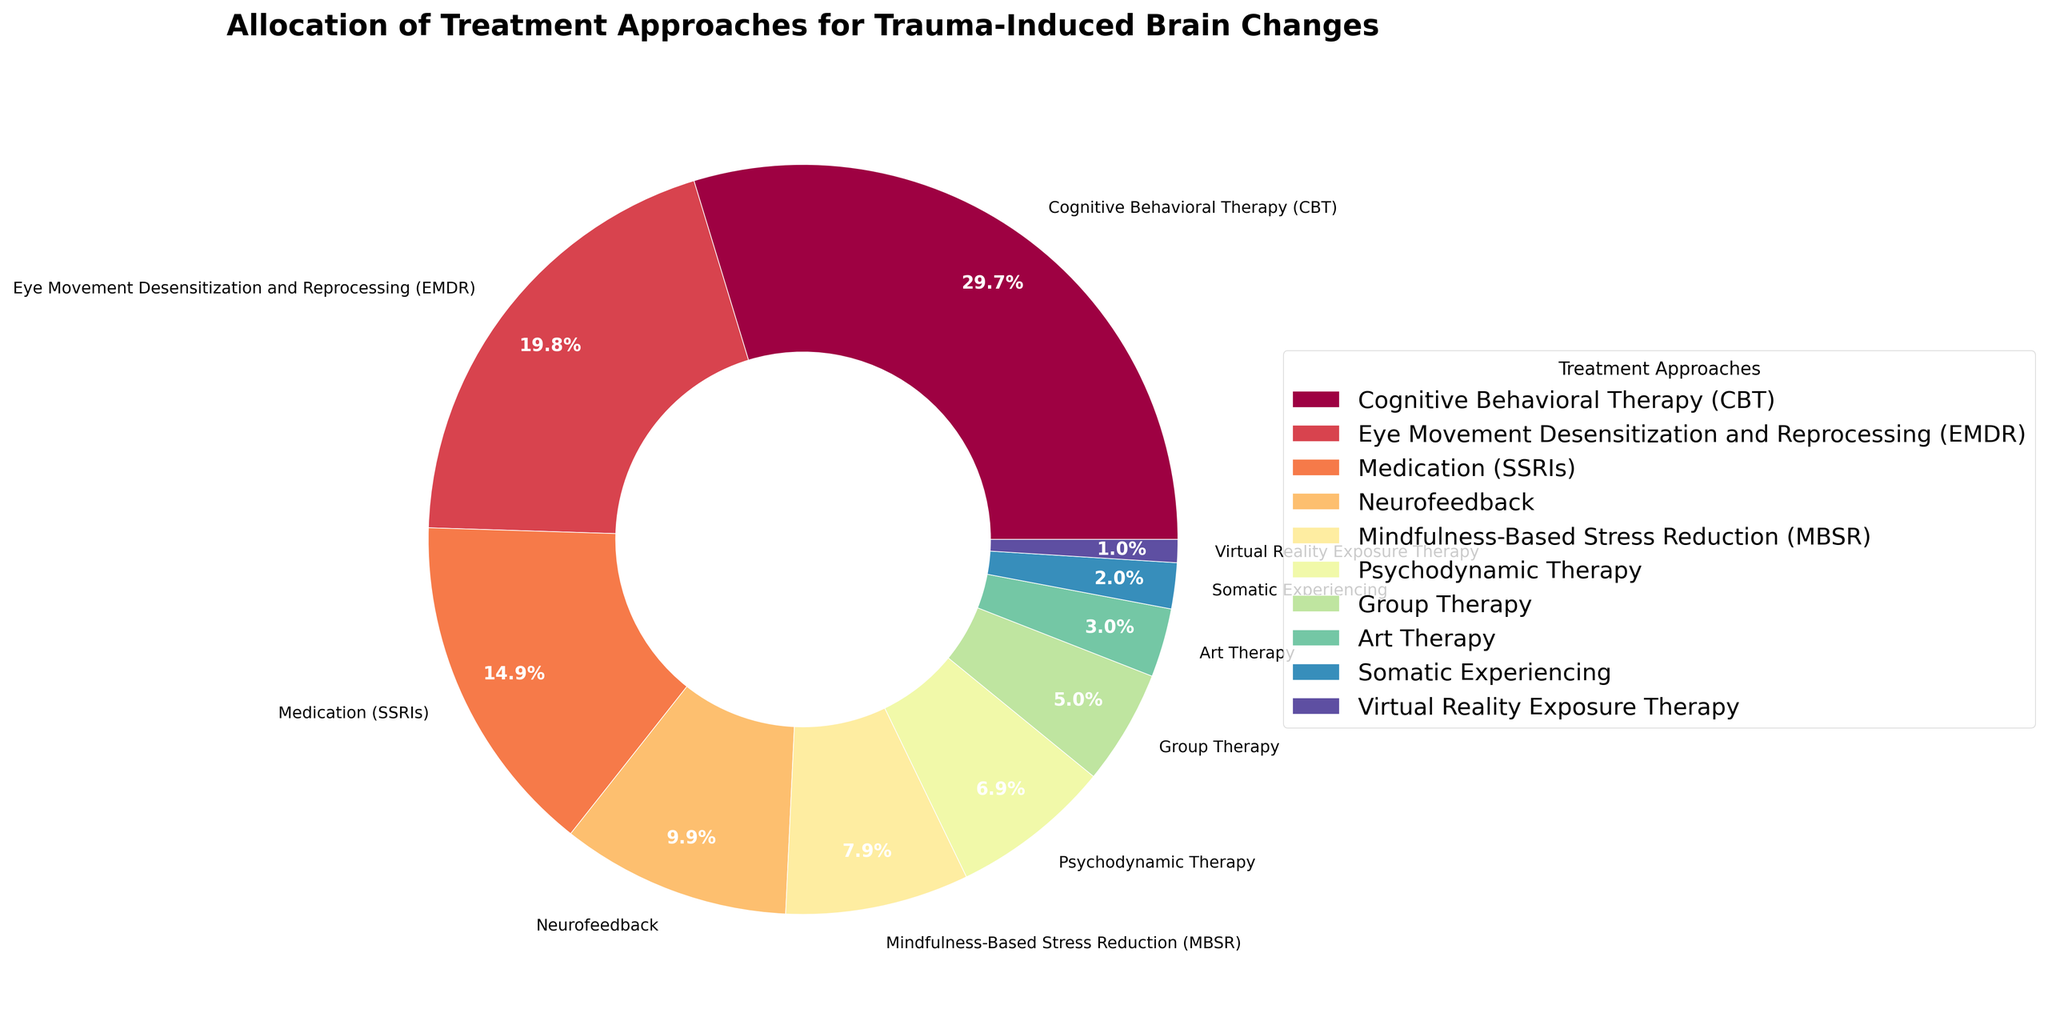What percentage of treatment approaches does Cognitive Behavioral Therapy (CBT) represent? Look at the segment labeled "Cognitive Behavioral Therapy (CBT)" on the pie chart. The percentage value next to the label indicates it represents 30%.
Answer: 30% Which treatment approach has the smallest allocation, and what is its percentage? Identify the smallest segment or the smallest value in the legend. The segment labeled "Virtual Reality Exposure Therapy" is the smallest with 1%.
Answer: Virtual Reality Exposure Therapy, 1% What is the combined percentage of Eye Movement Desensitization and Reprocessing (EMDR) and Medication (SSRIs)? Find and add the percentages of EMDR (20%) and Medication (SSRIs) (15%) from the pie chart. The sum is 20% + 15% = 35%.
Answer: 35% Which treatment approach is allocated more: Psychodynamic Therapy or Group Therapy, and by how much? Compare the percentages of Psychodynamic Therapy (7%) and Group Therapy (5%). Psychodynamic Therapy is more by 2% (7% - 5%).
Answer: Psychodynamic Therapy, 2% How many treatment approaches have an allocation of less than 10%? Identify all segments with percentages less than 10% and count them: Neurofeedback (10%), Mindfulness-Based Stress Reduction (8%), Psychodynamic Therapy (7%), Group Therapy (5%), Art Therapy (3%), Somatic Experiencing (2%), Virtual Reality Exposure Therapy (1%). There are 7 segments.
Answer: 7 What colors represent Cognitive Behavioral Therapy (CBT) and Eye Movement Desensitization and Reprocessing (EMDR) in the pie chart? Look at the color segments of the pie chart corresponding to the labels Cognitive Behavioral Therapy (CBT) and Eye Movement Desensitization and Reprocessing (EMDR). CBT is usually in the starting color, and EMDR will be in a subsequent color.
Answer: [Specific colors of the plotted chart] What is the majority treatment approach and what fraction of the total does it represent? The majority treatment approach is the one with the highest percentage. Cognitive Behavioral Therapy (CBT) has the highest percentage at 30%. The fraction is 30/100 which is 3/10 or 0.3.
Answer: Cognitive Behavioral Therapy (CBT), 3/10 What is the difference in percentage allocation between Art Therapy and Somatic Experiencing? Subtract the percentage of Somatic Experiencing (2%) from the percentage of Art Therapy (3%). The difference is 3% - 2% = 1%.
Answer: 1% Which treatment approaches together make up less than a quarter (25%) of the chart, and what are their combined percentages? Sum percentages of the smallest segments until less than 25% is reached: Virtual Reality Exposure Therapy (1%) + Somatic Experiencing (2%) + Art Therapy (3%) + Group Therapy (5%) + Psychodynamic Therapy (7%) = 1% + 2% + 3% + 5% + 7% = 18%.
Answer: Virtual Reality Exposure Therapy, Somatic Experiencing, Art Therapy, Group Therapy, Psychodynamic Therapy, 18% Is there a treatment approach colored with a color near the edges of the spectrum (red or violet), and which treatment does it represent? Identify the treatments near the start (Red) or end (Violet) of the spectrum. For instance, Cognitive Behavioral Therapy might be red, and Virtual Reality Exposure Therapy might be violet. Look at the treated list with corresponding colors.
Answer: [Specific treatment based on given color] 